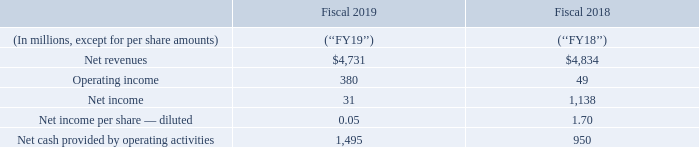FY19 Financial Results
FY19 Challenges
While we saw improvements in some areas of our business, our overall performance and stock price was negatively impacted by several significant factors: • Revenue and business momentum in our former Enterprise Security segment declined in FY19. • The Company was subject to an internal investigation, which was commenced and completed by the Audit Committee of the Board (the ‘‘Audit Committee’’) in connection with concerns raised by a former employee. • We announced a restructuring plan pursuant to which we targeted reductions of our global workforce of up to approximately 8%. • Our executive leadership team was in transition with announced executive officer departures in November 2018 and January 2019.
How much reduction in global workforce is in the restructuring plan? Up to approximately 8%. What does the table show? Fy19 financial results. How was overall performance and stock price in FY19? Negatively impacted. How many diluted shares were there in FY19 ? (31 millions)/0.05
Answer: 620000000. What is the average net revenue for a Fiscal year?
Answer scale should be: million. (4,731+4,834)/2
Answer: 4782.5. What is Net income expressed as a percentage of Net revenues for FY19?
Answer scale should be: percent. 31/4,731
Answer: 0.66. 